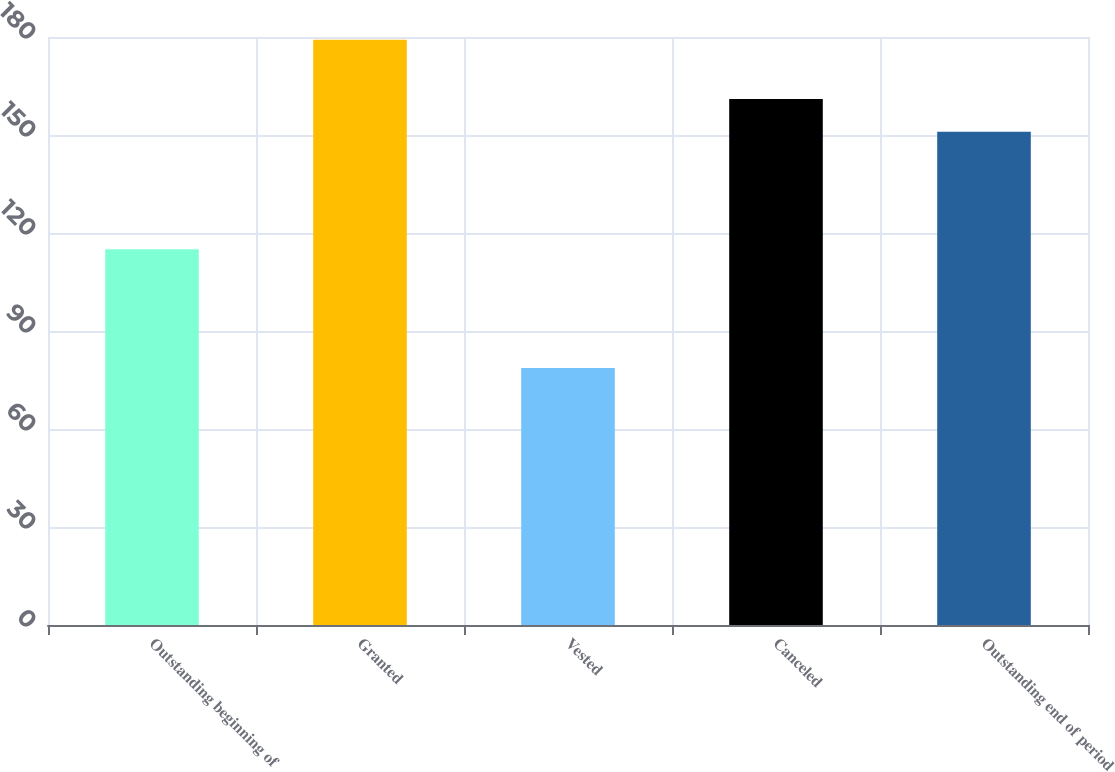Convert chart to OTSL. <chart><loc_0><loc_0><loc_500><loc_500><bar_chart><fcel>Outstanding beginning of<fcel>Granted<fcel>Vested<fcel>Canceled<fcel>Outstanding end of period<nl><fcel>115.01<fcel>179.17<fcel>78.65<fcel>161.01<fcel>150.96<nl></chart> 